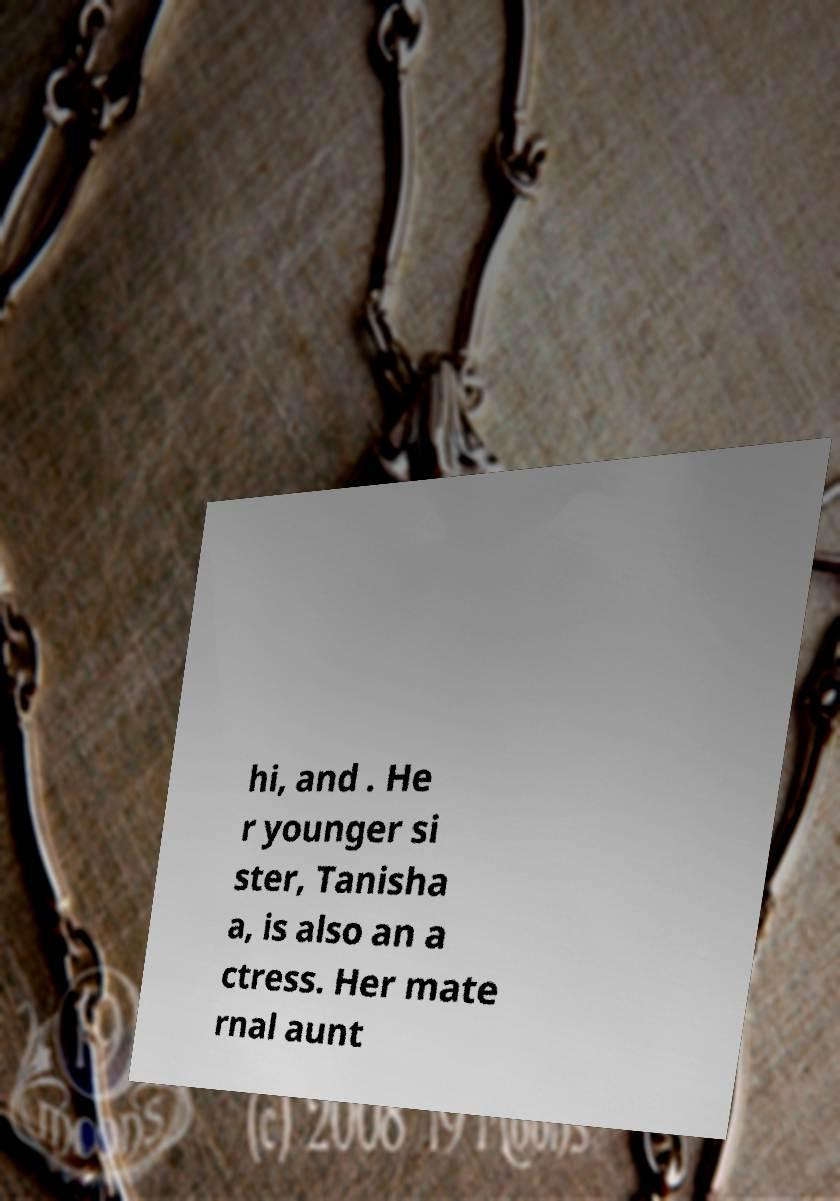For documentation purposes, I need the text within this image transcribed. Could you provide that? hi, and . He r younger si ster, Tanisha a, is also an a ctress. Her mate rnal aunt 